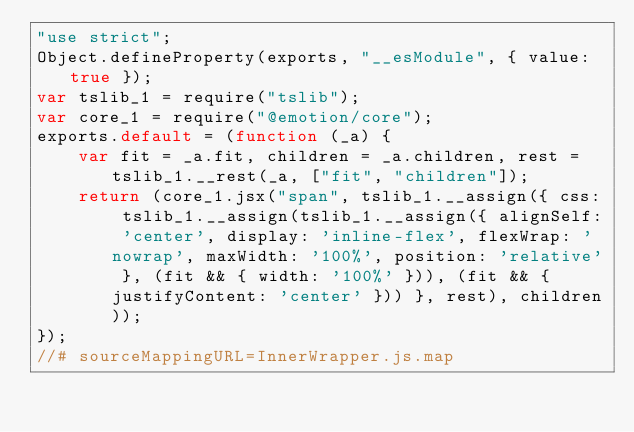Convert code to text. <code><loc_0><loc_0><loc_500><loc_500><_JavaScript_>"use strict";
Object.defineProperty(exports, "__esModule", { value: true });
var tslib_1 = require("tslib");
var core_1 = require("@emotion/core");
exports.default = (function (_a) {
    var fit = _a.fit, children = _a.children, rest = tslib_1.__rest(_a, ["fit", "children"]);
    return (core_1.jsx("span", tslib_1.__assign({ css: tslib_1.__assign(tslib_1.__assign({ alignSelf: 'center', display: 'inline-flex', flexWrap: 'nowrap', maxWidth: '100%', position: 'relative' }, (fit && { width: '100%' })), (fit && { justifyContent: 'center' })) }, rest), children));
});
//# sourceMappingURL=InnerWrapper.js.map</code> 